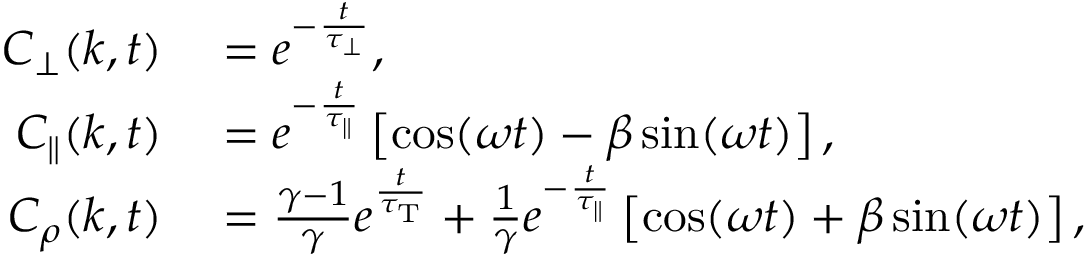Convert formula to latex. <formula><loc_0><loc_0><loc_500><loc_500>\begin{array} { r l } { C _ { \perp } ( k , t ) } & = e ^ { - \frac { t } { \tau _ { \perp } } } , } \\ { C _ { \| } ( k , t ) } & = e ^ { - \frac { t } { \tau _ { \| } } } \left [ \cos ( \omega t ) - \beta \sin ( \omega t ) \right ] , } \\ { C _ { \rho } ( k , t ) } & = \frac { \gamma - 1 } { \gamma } e ^ { \frac { t } { \tau _ { T } } } + \frac { 1 } { \gamma } e ^ { - \frac { t } { \tau _ { \| } } } \left [ \cos ( \omega t ) + \beta \sin ( \omega t ) \right ] , } \end{array}</formula> 